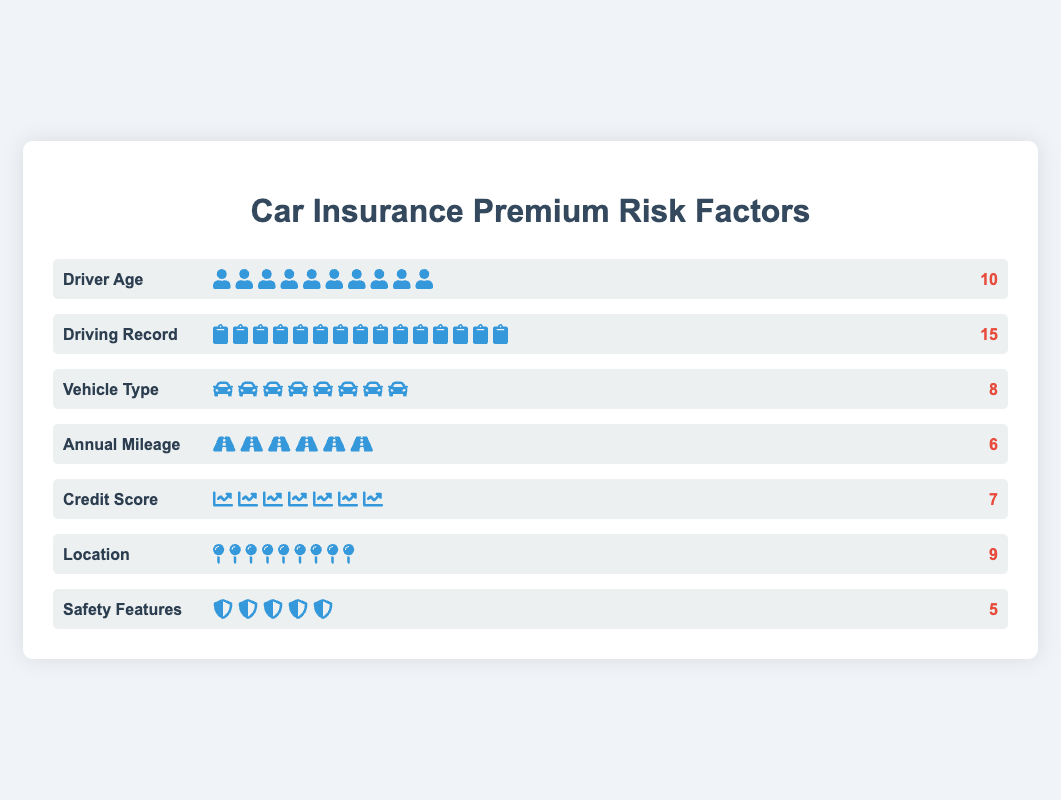Which risk factor has the highest impact on car insurance premiums? By observing the "impact value" of each risk factor, the one with the highest number will be identified. The "Driving Record" has an impact value of 15, which is the highest.
Answer: Driving Record How many icons represent the impact of "Vehicle Type"? By counting the number of car icons in the "Vehicle Type" factor row, you can determine the total number. There are 8 car icons.
Answer: 8 What is the combined impact of "Driver Age" and "Credit Score"? Adding the impact values of "Driver Age" (10) and "Credit Score" (7) gives the combined impact: 10 + 7 = 17.
Answer: 17 Which factor has a lower impact, "Annual Mileage" or "Location"? By comparing the impact values of "Annual Mileage" (6) and "Location" (9), "Annual Mileage" is identified to have a lower impact.
Answer: Annual Mileage What is the total number of factors shown in the plot? Counting the number of different factor rows (each row represents one factor), there are 7 risk factors listed.
Answer: 7 What is the difference in impact between the highest and lowest impact factors? The highest impact factor is "Driving Record" (15) and the lowest is "Safety Features" (5). The difference is 15 - 5 = 10.
Answer: 10 Which two factors have an equal number of icons representing their impact? By comparing the number of icons for each factor, both "Driver Age" and "Location" have 9 icons each.
Answer: Driver Age and Location What is the average impact of all the risk factors combined? Adding up all the impact values (10, 15, 8, 6, 7, 9, 5) gives a total of 60. Dividing by the number of factors (7) results in an average impact of approximately 8.57.
Answer: 8.57 In terms of visual comparison, which factor's icons are the least numerous? Observing the visually displayed counts of icons, "Safety Features" has the least with 5 icons.
Answer: Safety Features 